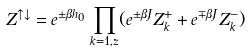Convert formula to latex. <formula><loc_0><loc_0><loc_500><loc_500>Z ^ { \uparrow \downarrow } = e ^ { \pm \beta h _ { 0 } } \prod _ { k = 1 , z } ( e ^ { \pm \beta J } Z _ { k } ^ { + } + e ^ { \mp \beta J } Z _ { k } ^ { - } )</formula> 